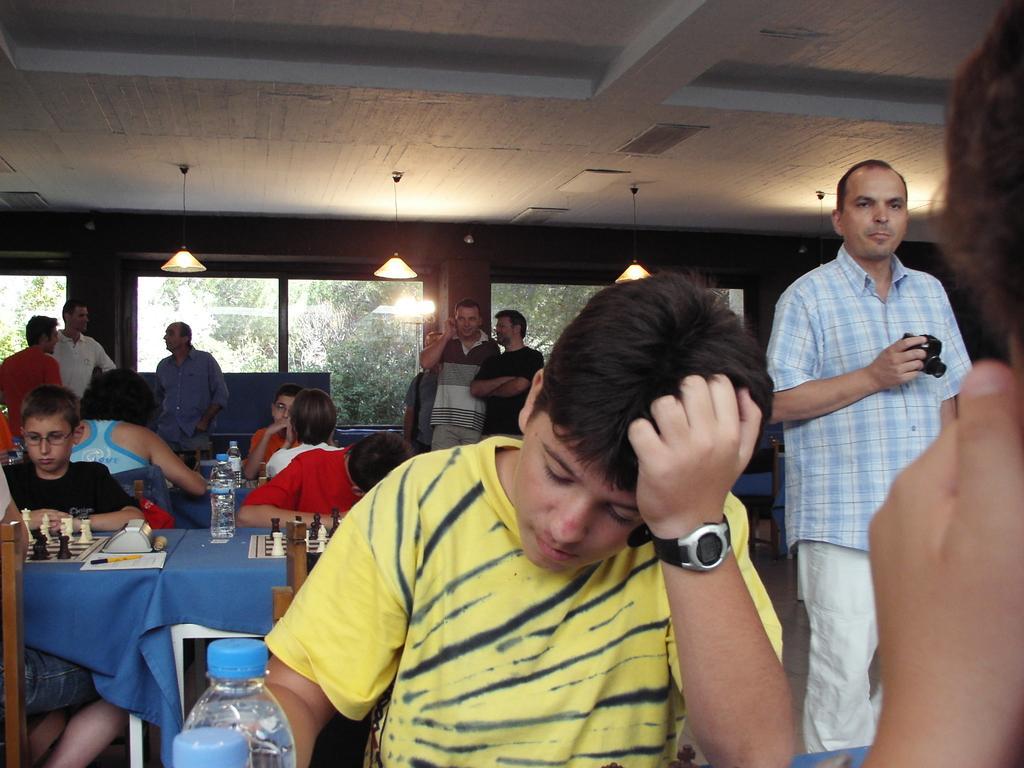How would you summarize this image in a sentence or two? In this image there is a boy in the middle who is keeping his hand on his head. In the background there are few kids who are playing the chess. In front of them there is a table on which there are chess boards,bottles and papers. At the top there are lights which are hanged. In the background there are few people who are standing on the floor. Behind them there are glass windows through which we can see the trees. 